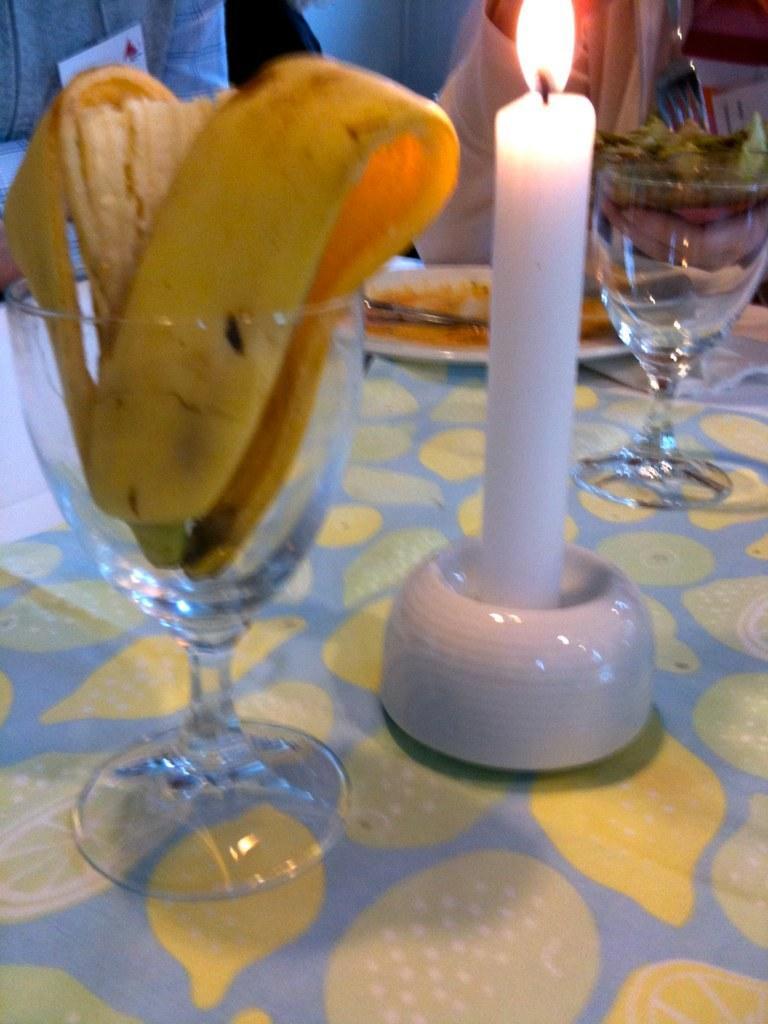How would you summarize this image in a sentence or two? In this picture there is a table in the center of the image, on which there are glasses, food items, and a candle, there are people at the top side of the image. 